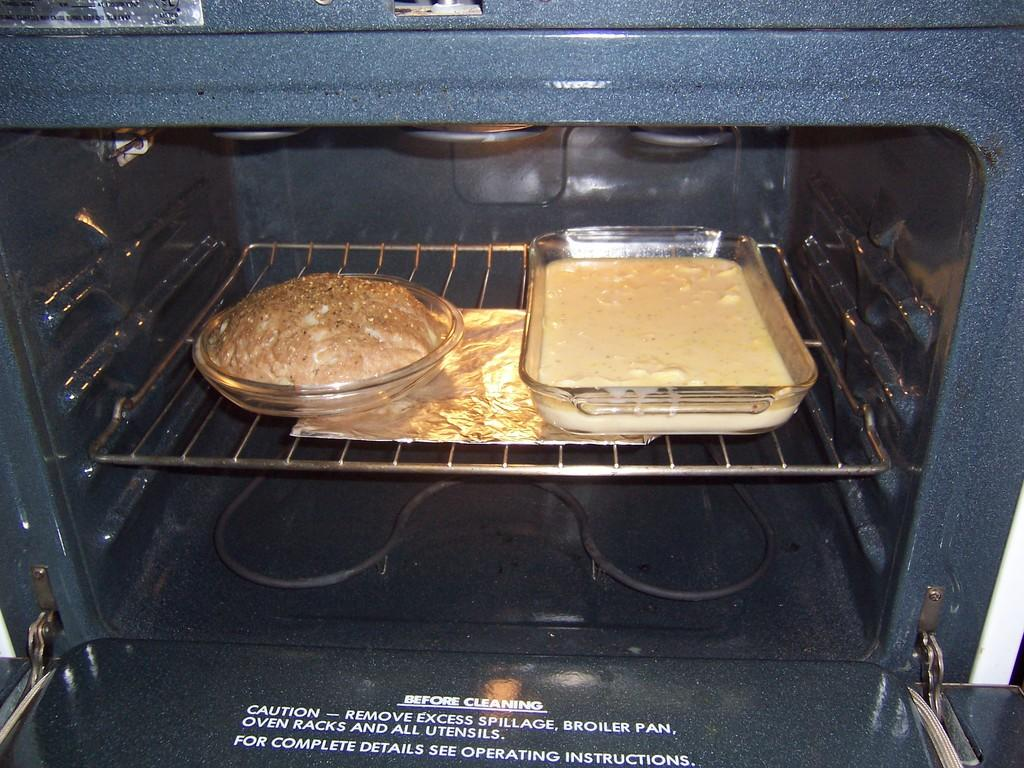<image>
Summarize the visual content of the image. Two unbaked cakes inside an oven with the word CAUTION on the inside of the door. 